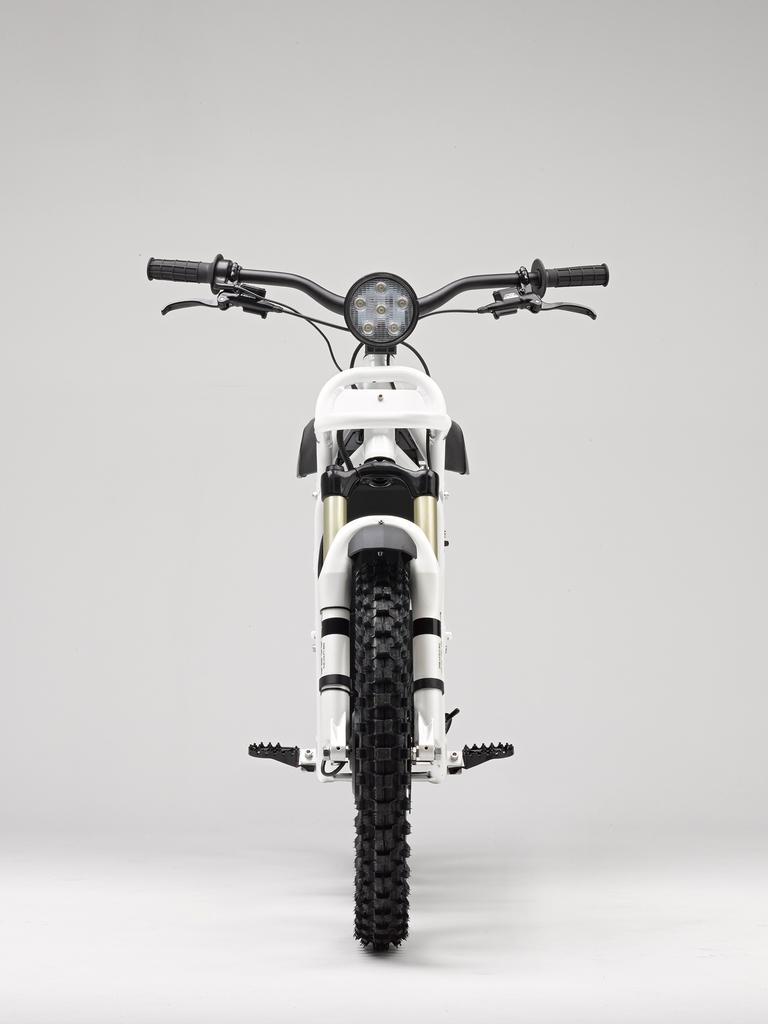What is the main subject of the picture? The main subject of the picture is a bicycle. In which direction is the bicycle facing? The bicycle is facing forward. What color is the background of the image? The background of the image is white. Can you see any wings on the bicycle in the image? No, there are no wings present on the bicycle in the image. Is there a cap on the bicycle in the image? No, there is no cap present on the bicycle in the image. 